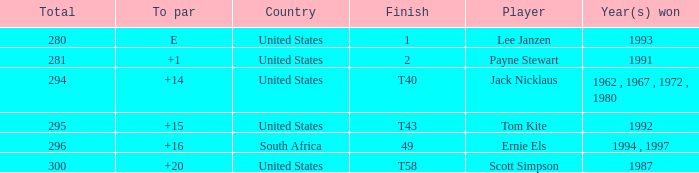What is the Total of the Player with a Finish of 1? 1.0. 